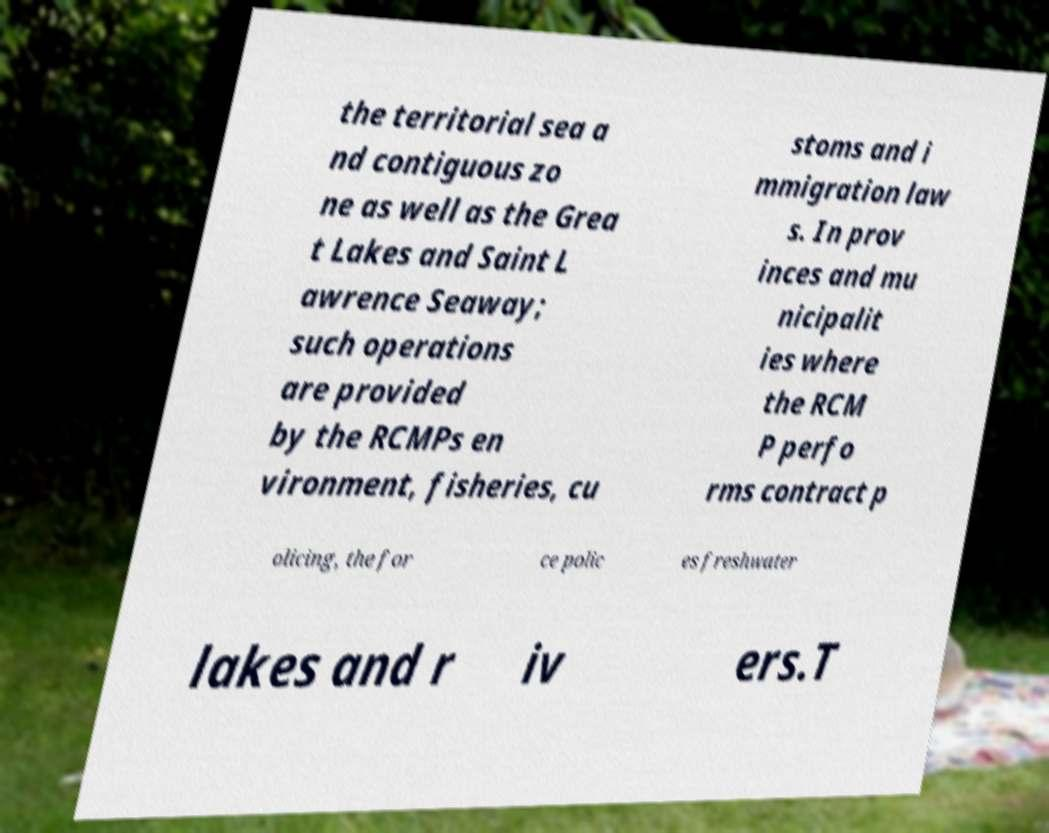There's text embedded in this image that I need extracted. Can you transcribe it verbatim? the territorial sea a nd contiguous zo ne as well as the Grea t Lakes and Saint L awrence Seaway; such operations are provided by the RCMPs en vironment, fisheries, cu stoms and i mmigration law s. In prov inces and mu nicipalit ies where the RCM P perfo rms contract p olicing, the for ce polic es freshwater lakes and r iv ers.T 